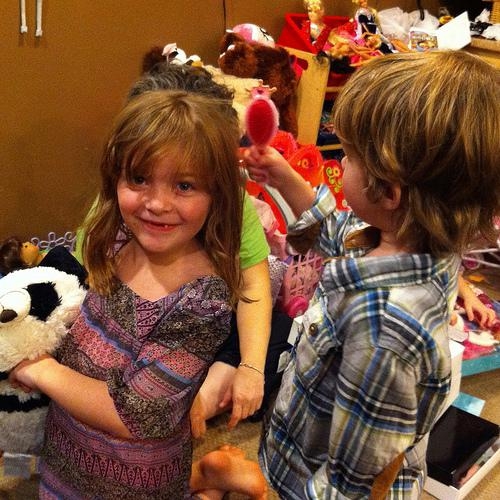Question: how is the photo?
Choices:
A. Blurry.
B. Sharp.
C. Clear.
D. Out of focus.
Answer with the letter. Answer: C Question: who is in the photo?
Choices:
A. Swimmers.
B. Runners.
C. Children.
D. Hikers.
Answer with the letter. Answer: C Question: why is the photo clear?
Choices:
A. It's indoors.
B. It's a bright day.
C. The focus is super sharp.
D. Long exposure time.
Answer with the letter. Answer: A Question: where was the photo taken?
Choices:
A. Studio.
B. Toy store.
C. School.
D. Beach.
Answer with the letter. Answer: B 